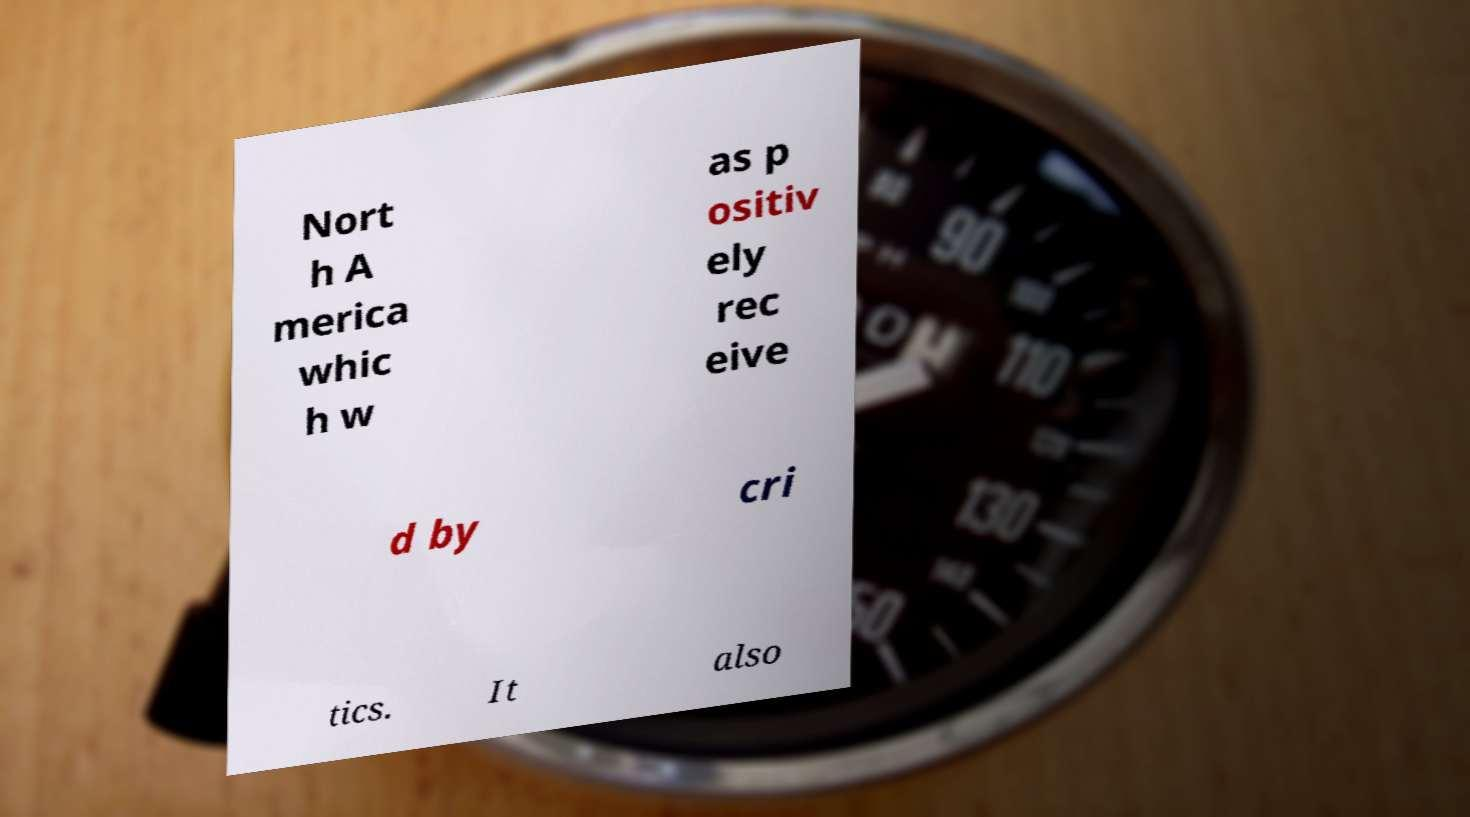Could you assist in decoding the text presented in this image and type it out clearly? Nort h A merica whic h w as p ositiv ely rec eive d by cri tics. It also 